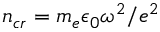Convert formula to latex. <formula><loc_0><loc_0><loc_500><loc_500>n _ { c r } = m _ { e } \epsilon _ { 0 } \omega ^ { 2 } / e ^ { 2 }</formula> 